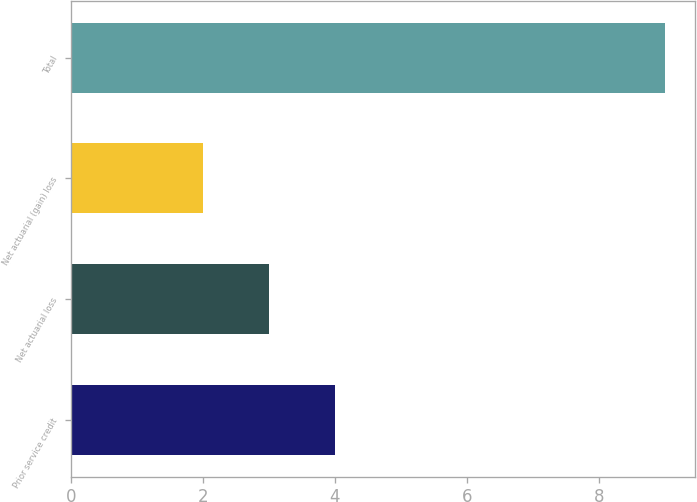Convert chart. <chart><loc_0><loc_0><loc_500><loc_500><bar_chart><fcel>Prior service credit<fcel>Net actuarial loss<fcel>Net actuarial (gain) loss<fcel>Total<nl><fcel>4<fcel>3<fcel>2<fcel>9<nl></chart> 